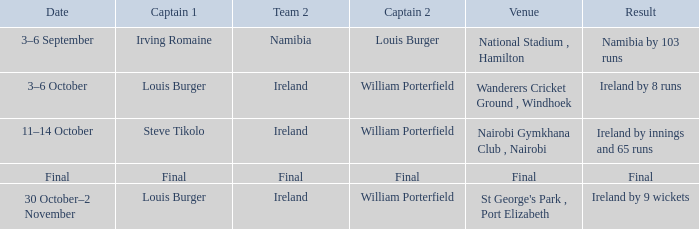Which captain 2 achieved a result of ireland winning by 8 runs? William Porterfield. Parse the full table. {'header': ['Date', 'Captain 1', 'Team 2', 'Captain 2', 'Venue', 'Result'], 'rows': [['3–6 September', 'Irving Romaine', 'Namibia', 'Louis Burger', 'National Stadium , Hamilton', 'Namibia by 103 runs'], ['3–6 October', 'Louis Burger', 'Ireland', 'William Porterfield', 'Wanderers Cricket Ground , Windhoek', 'Ireland by 8 runs'], ['11–14 October', 'Steve Tikolo', 'Ireland', 'William Porterfield', 'Nairobi Gymkhana Club , Nairobi', 'Ireland by innings and 65 runs'], ['Final', 'Final', 'Final', 'Final', 'Final', 'Final'], ['30 October–2 November', 'Louis Burger', 'Ireland', 'William Porterfield', "St George's Park , Port Elizabeth", 'Ireland by 9 wickets']]} 